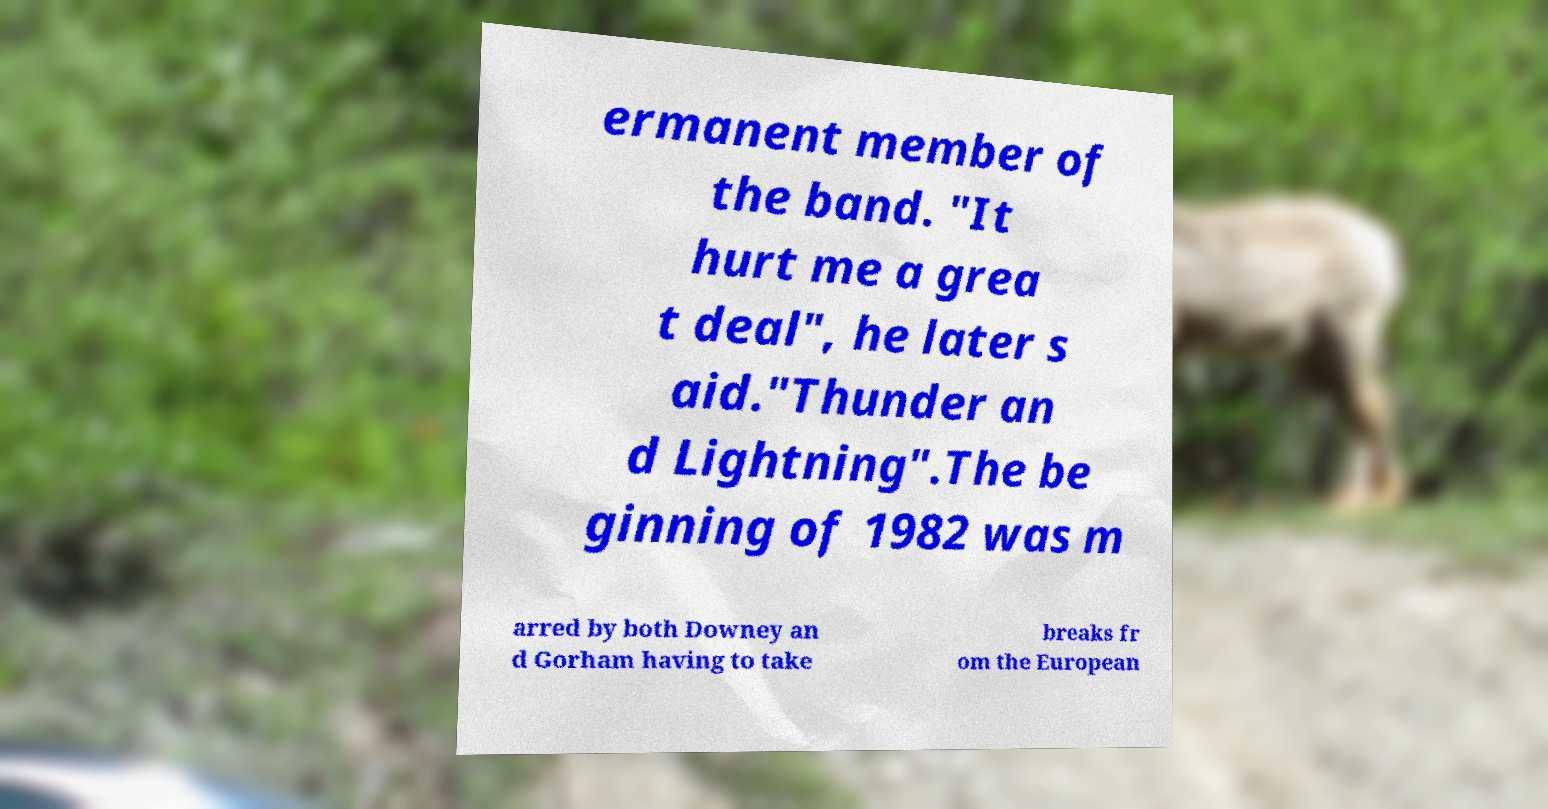Could you extract and type out the text from this image? ermanent member of the band. "It hurt me a grea t deal", he later s aid."Thunder an d Lightning".The be ginning of 1982 was m arred by both Downey an d Gorham having to take breaks fr om the European 